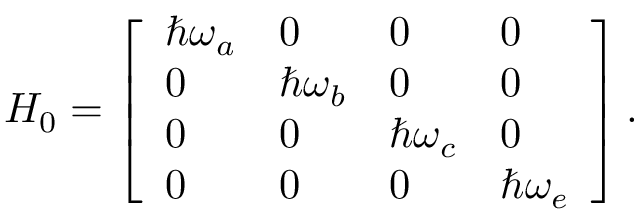Convert formula to latex. <formula><loc_0><loc_0><loc_500><loc_500>H _ { 0 } = \left [ \begin{array} { l l l l } { \hbar { \omega } _ { a } } & { 0 } & { 0 } & { 0 } \\ { 0 } & { \hbar { \omega } _ { b } } & { 0 } & { 0 } \\ { 0 } & { 0 } & { \hbar { \omega } _ { c } } & { 0 } \\ { 0 } & { 0 } & { 0 } & { \hbar { \omega } _ { e } } \end{array} \right ] .</formula> 